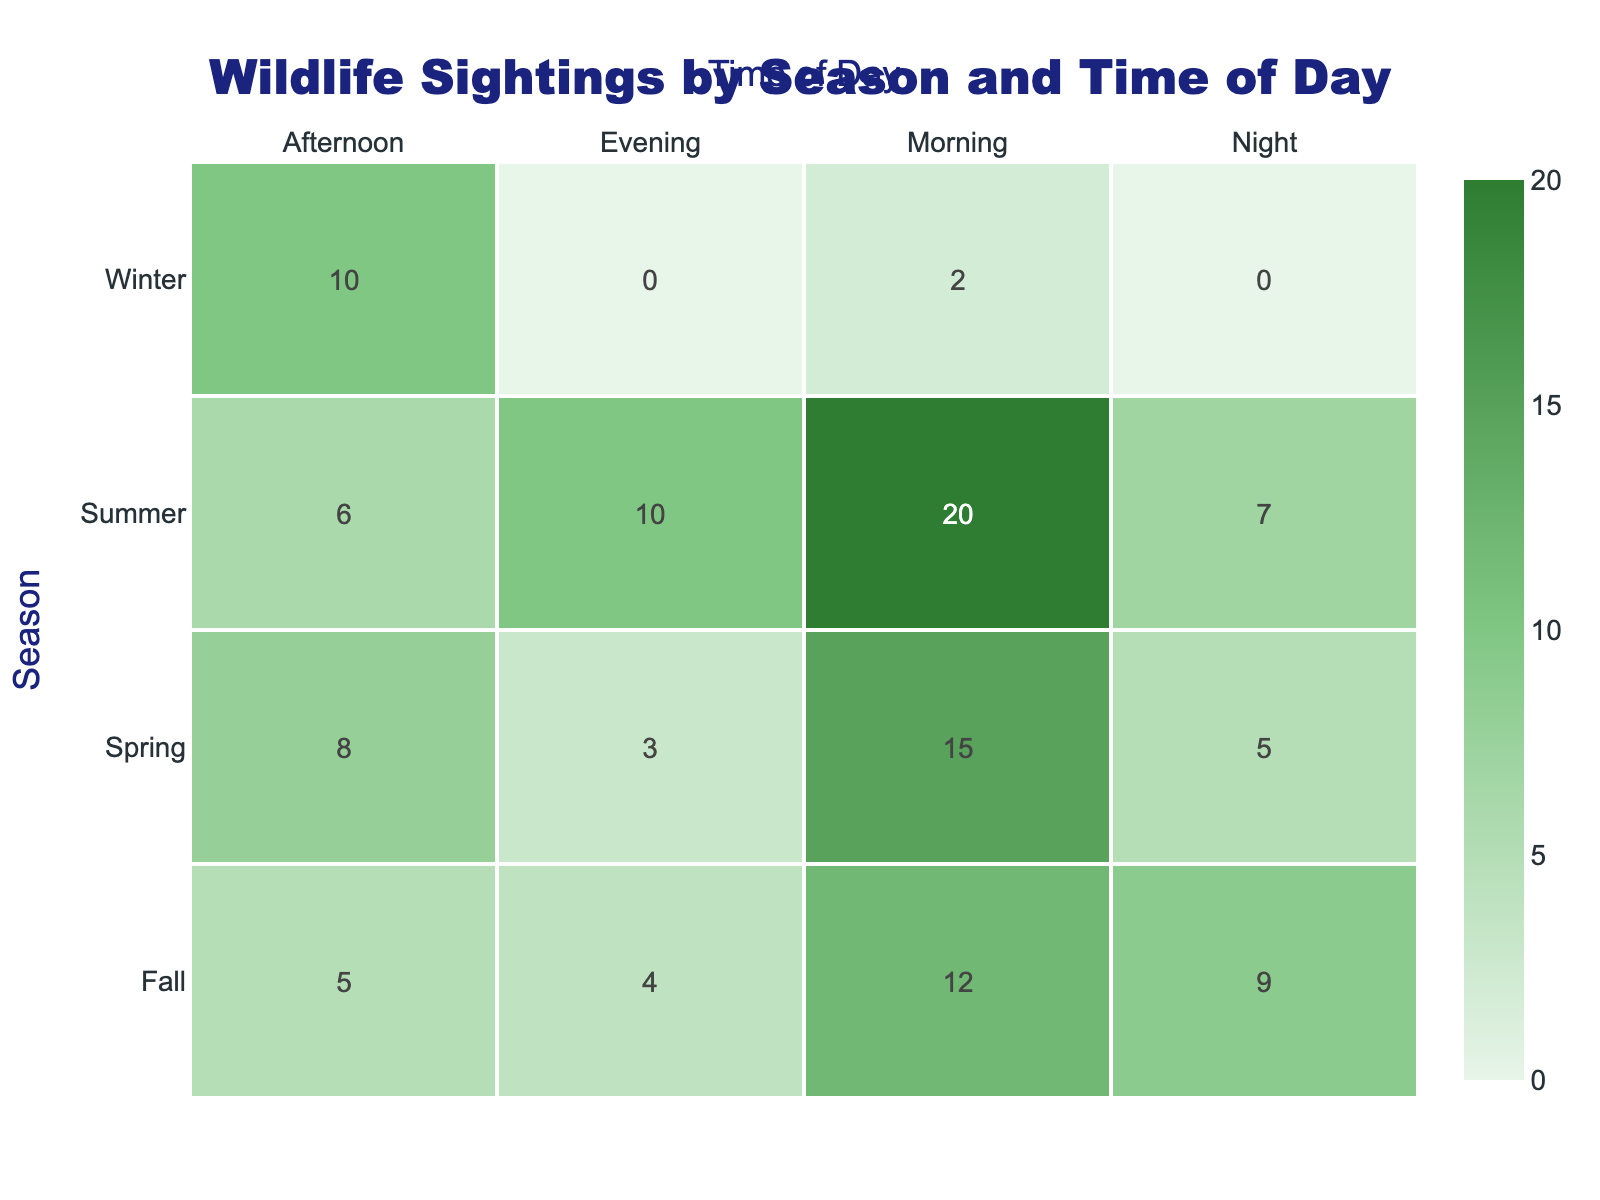What wildlife was sighted the most during the morning in spring? The data shows that in spring, squirrels were sighted the most in the morning with a count of 15.
Answer: Squirrels What is the total count of wildlife sightings in summer? The total count for summer can be calculated by adding the counts of all wildlife sighted: 20 (birds) + 6 (foxes) + 10 (bats) + 7 (coyotes) = 43.
Answer: 43 Did more wildlife sightings occur during the night in fall compared to winter? In fall, the total count of wildlife sightings during the night is 9 (possums), and in winter, it is 2 (owls). Since 9 is greater than 2, the statement is true.
Answer: Yes Which season had the lowest count of wildlife sightings during the afternoon? Looking at the afternoon counts, spring had 8 (rabbits), summer had 6 (foxes), fall had 5 (turkeys), and winter had 10 (cardinals). The lowest count is 5 in fall.
Answer: Fall What was the total count of all wildlife sightings across all seasons and times of day? To find the total, we calculate by summing all counts: 15 + 8 + 3 + 5 + 20 + 6 + 10 + 7 + 12 + 5 + 4 + 9 + 2 + 10 = 92.
Answer: 92 Which time of day had the highest wildlife sightings in the summer season? In summer, the morning had 20 (birds), afternoon had 6 (foxes), evening had 10 (bats), and night had 7 (coyotes). The highest is 20 in the morning.
Answer: Morning Is it true that deer sightings were only reported in the spring? The data indicates that deer were sighted only in the spring (count of 3) and not in any other season. Therefore, the statement is true.
Answer: Yes What is the difference in wildlife sightings between fall evening and winter afternoon? In the fall evening, the count is 4 (hedgehogs), and in winter afternoon, it is 10 (cardinals). The difference is 10 - 4 = 6.
Answer: 6 